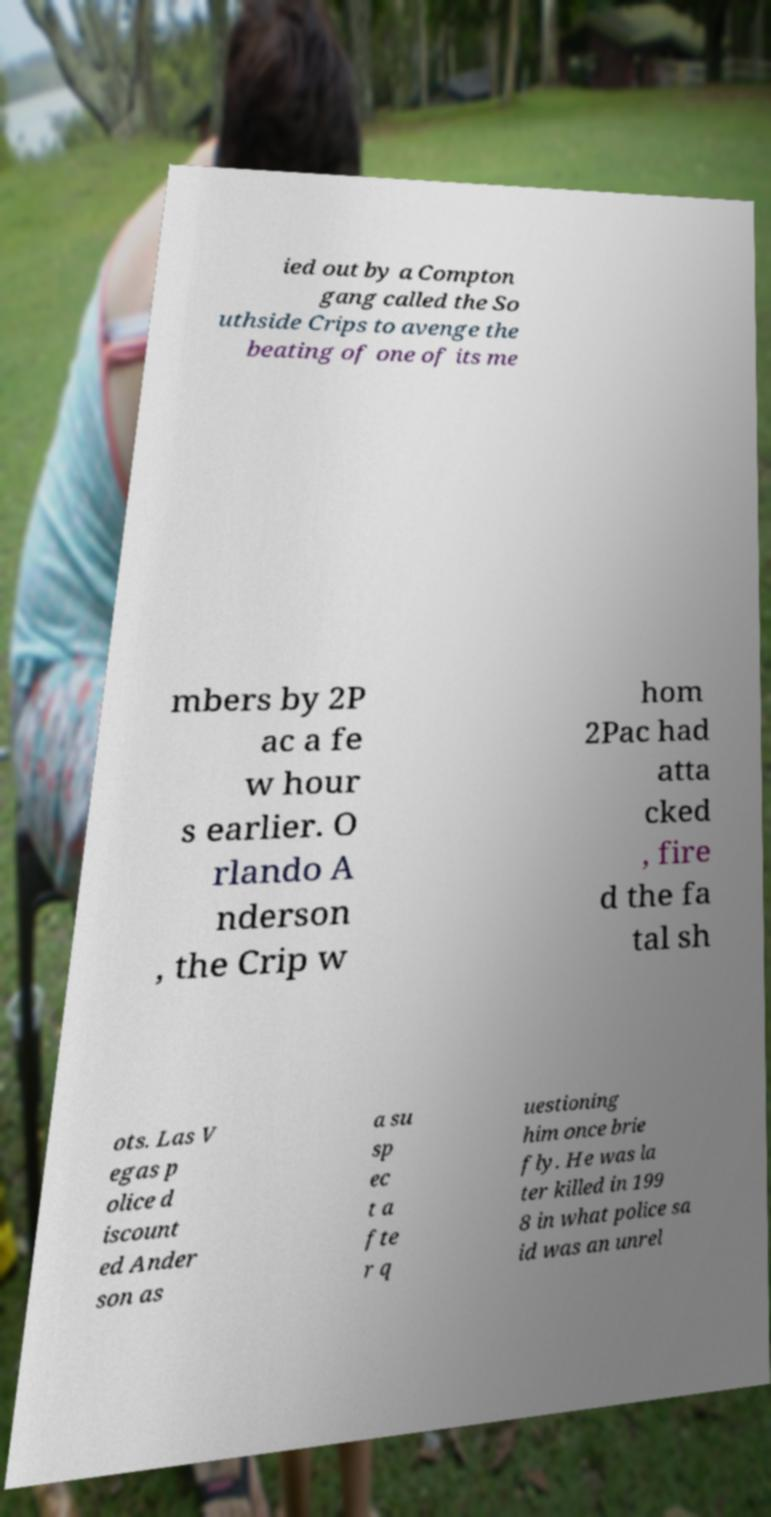For documentation purposes, I need the text within this image transcribed. Could you provide that? ied out by a Compton gang called the So uthside Crips to avenge the beating of one of its me mbers by 2P ac a fe w hour s earlier. O rlando A nderson , the Crip w hom 2Pac had atta cked , fire d the fa tal sh ots. Las V egas p olice d iscount ed Ander son as a su sp ec t a fte r q uestioning him once brie fly. He was la ter killed in 199 8 in what police sa id was an unrel 